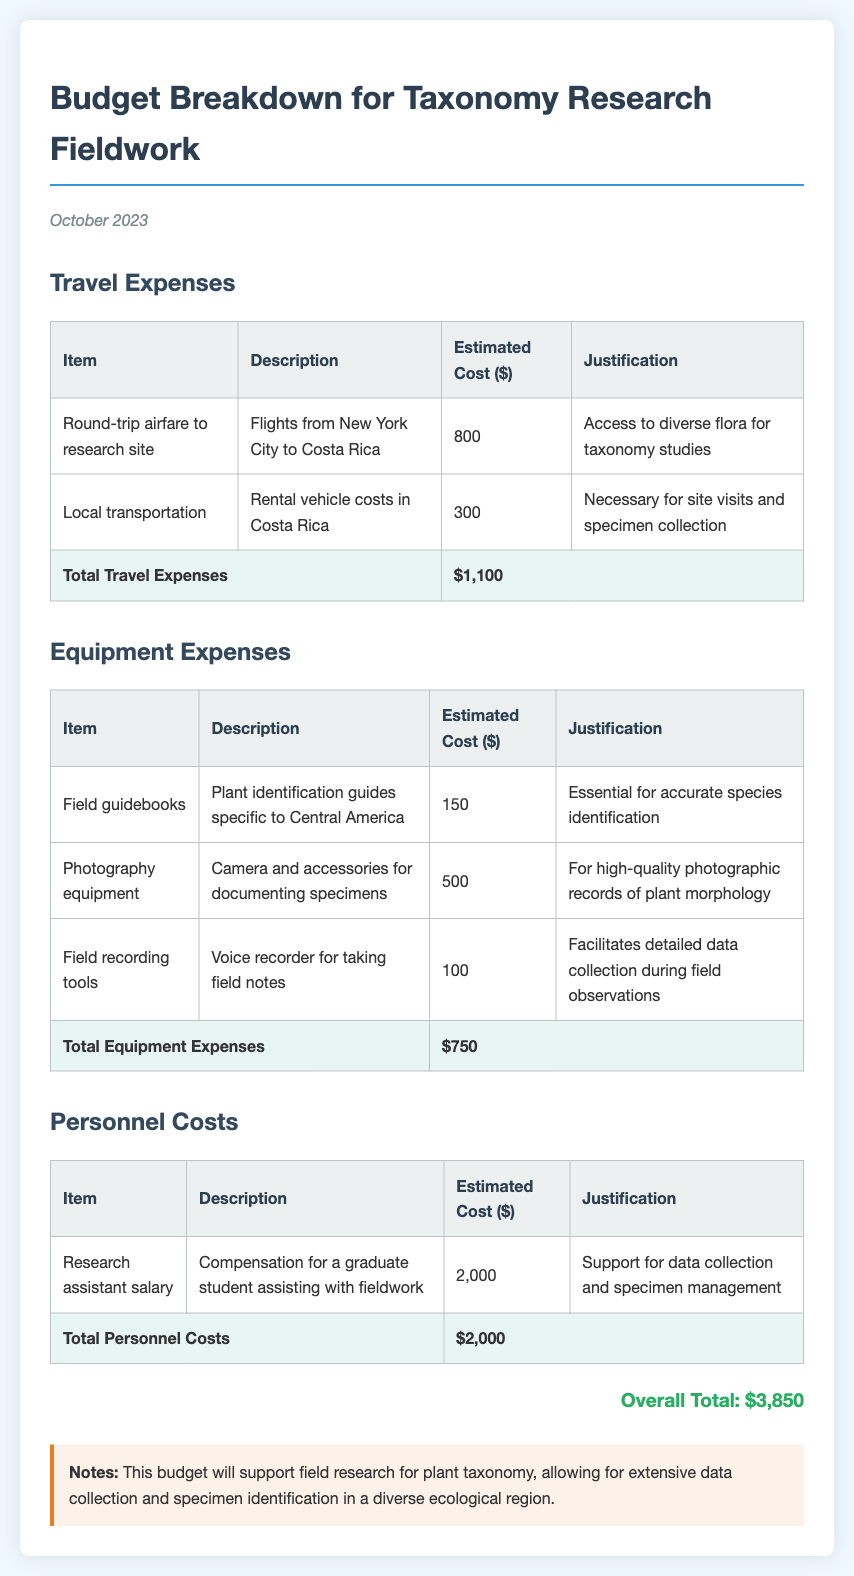what is the total travel expenses? The total travel expenses are the sum of the individual travel costs listed, which is 800 + 300 = 1100.
Answer: $1,100 what is the estimated cost for photography equipment? The estimated cost for photography equipment is listed in the equipment expenses table.
Answer: $500 how much is allocated for personnel costs? The total personnel costs are specified at the end of the personnel costs table.
Answer: $2,000 what is the overall total budget for fieldwork? The overall total is mentioned at the bottom of the document, calculated from all expenses combined.
Answer: $3,850 why is local transportation necessary? The justification for local transportation explains its role in site visits and specimen collection.
Answer: Necessary for site visits and specimen collection how many items are listed under equipment expenses? The number of rows in the equipment expenses table minus the total row gives the count of items.
Answer: 3 